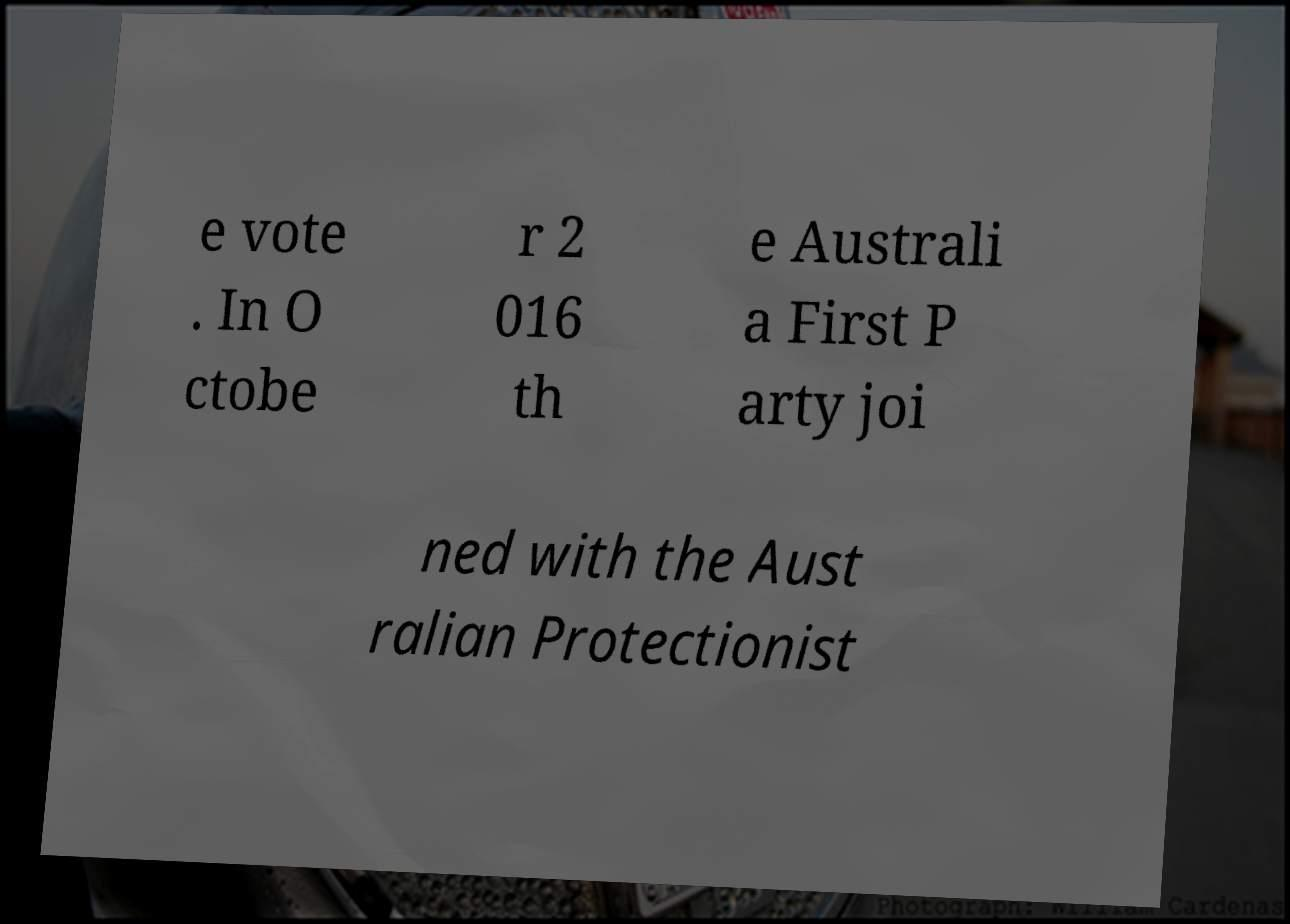I need the written content from this picture converted into text. Can you do that? e vote . In O ctobe r 2 016 th e Australi a First P arty joi ned with the Aust ralian Protectionist 